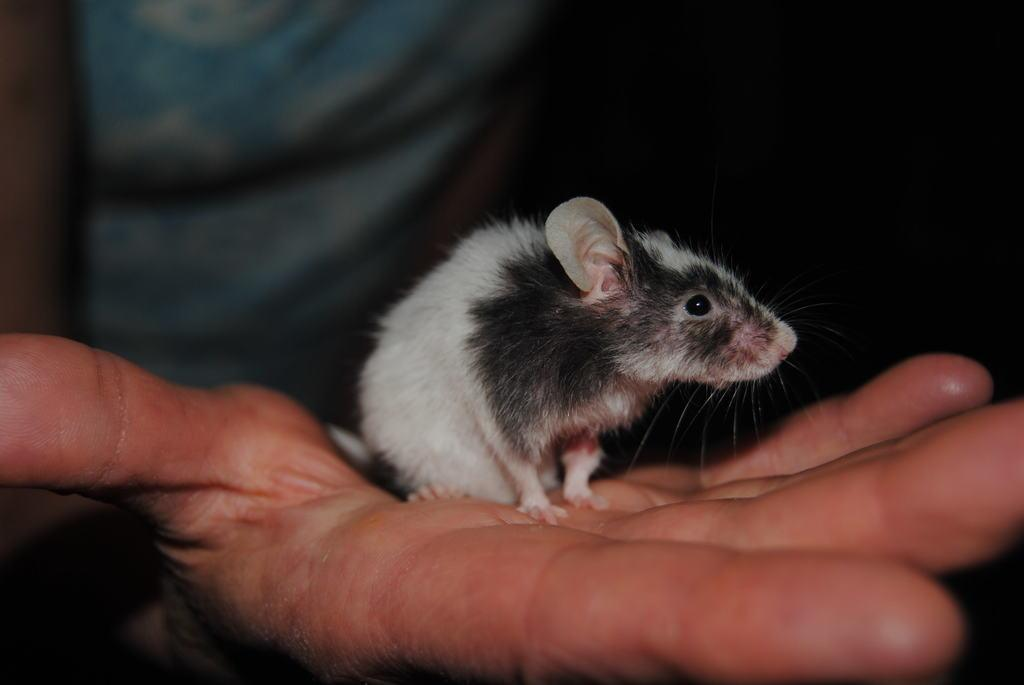What can be seen in the image? There is a person's hand in the image. What is the color of the background in the image? The background of the image is dark. What is the person holding in their hand? There is a rat in the person's hand. What songs can be heard playing in the background of the image? There is no audio or music present in the image, so it's not possible to determine what songs might be heard. 